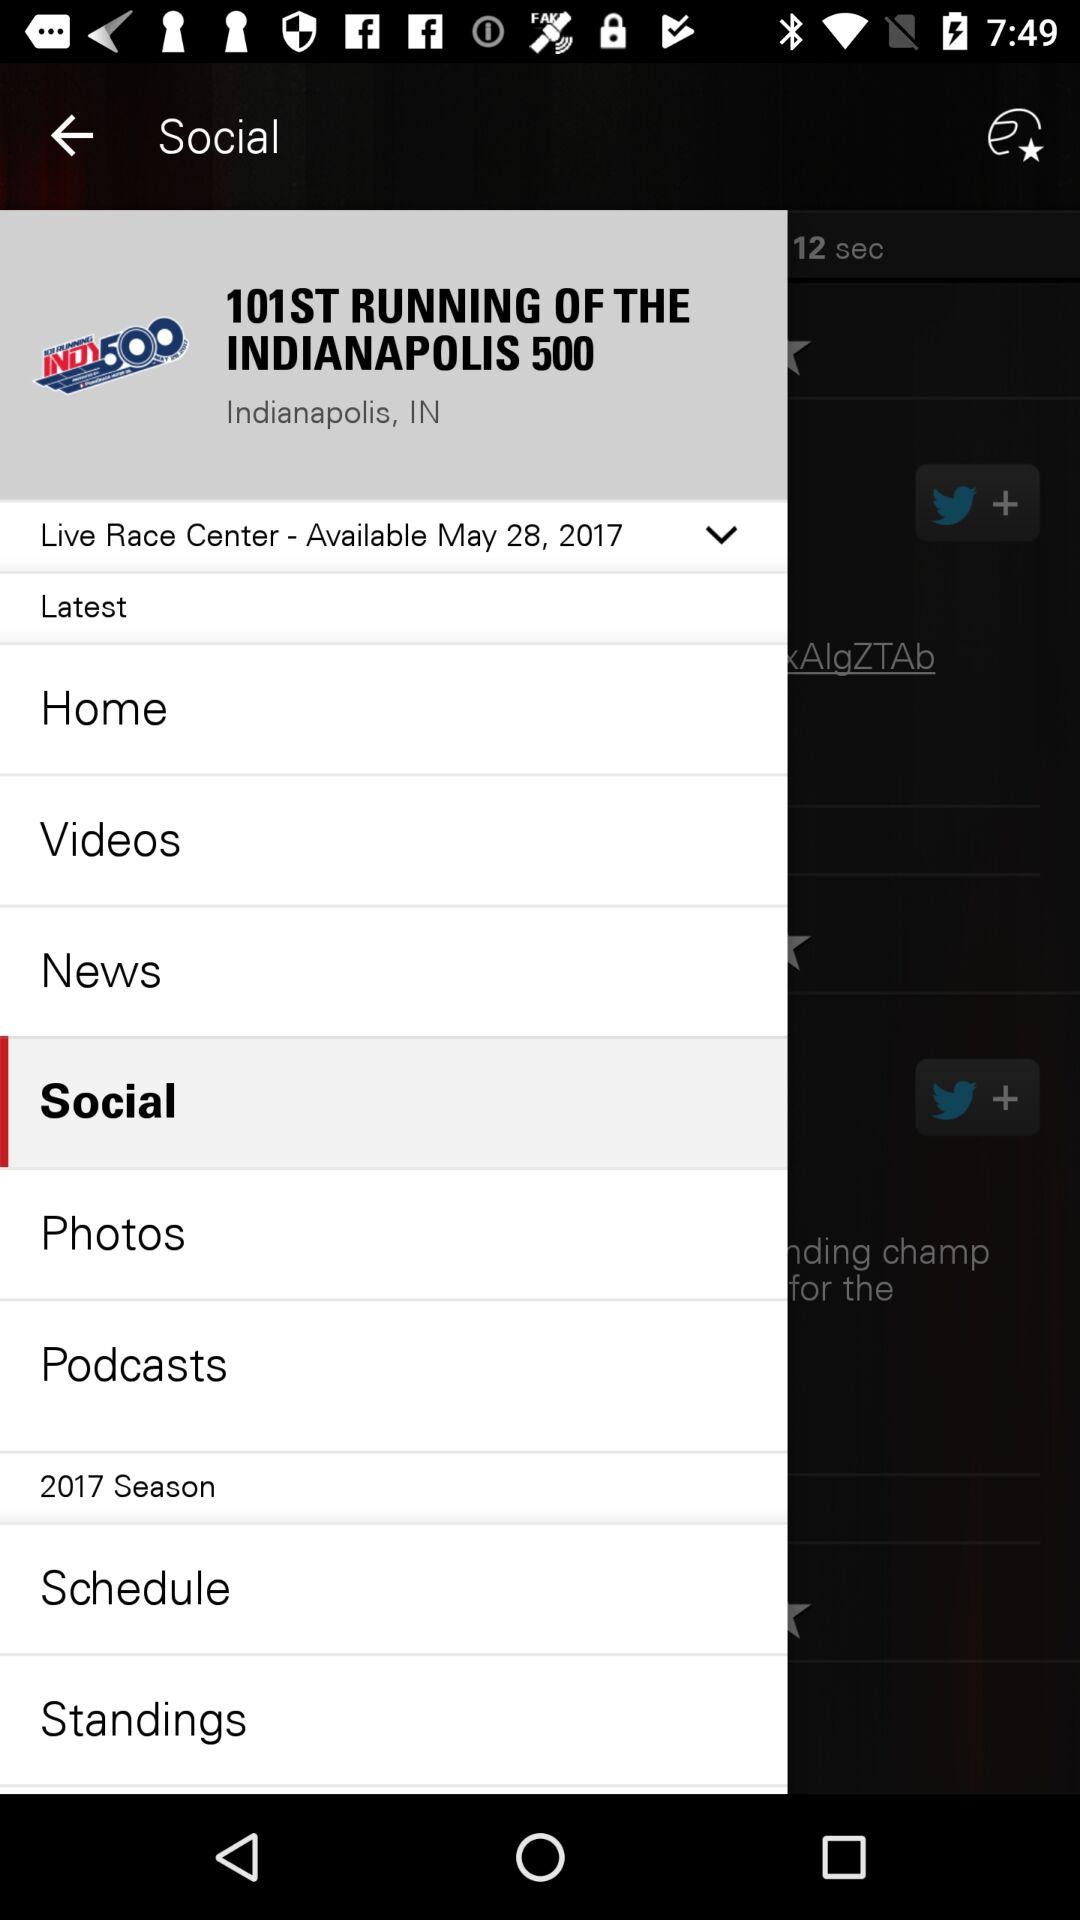What is the given location? The given location is Indianapolis, IN. 